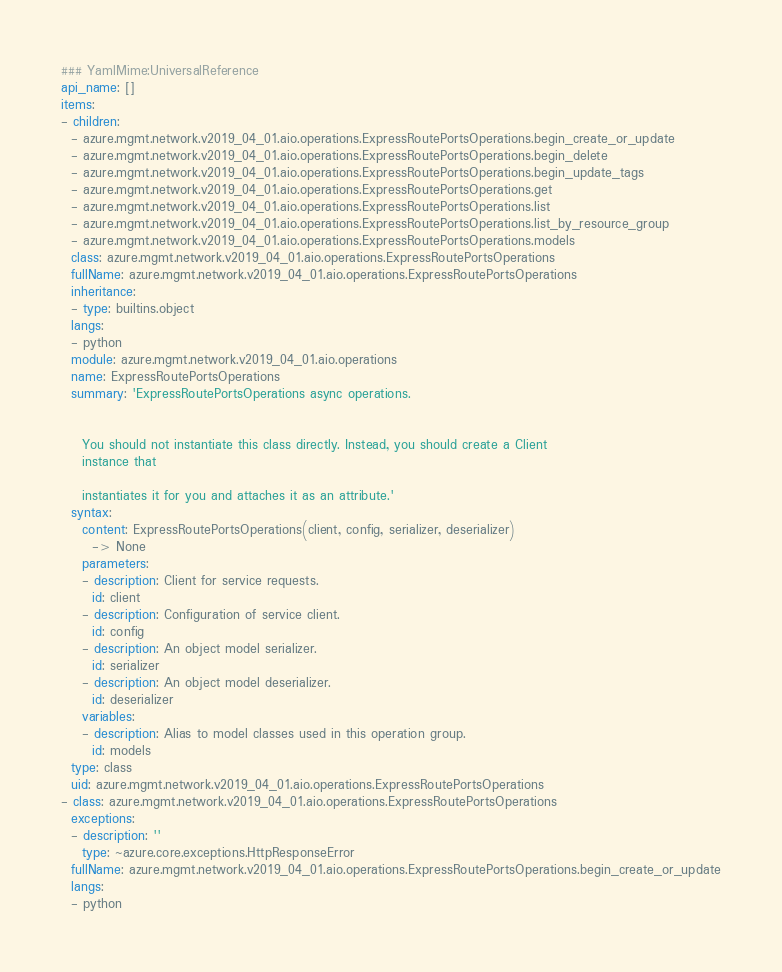Convert code to text. <code><loc_0><loc_0><loc_500><loc_500><_YAML_>### YamlMime:UniversalReference
api_name: []
items:
- children:
  - azure.mgmt.network.v2019_04_01.aio.operations.ExpressRoutePortsOperations.begin_create_or_update
  - azure.mgmt.network.v2019_04_01.aio.operations.ExpressRoutePortsOperations.begin_delete
  - azure.mgmt.network.v2019_04_01.aio.operations.ExpressRoutePortsOperations.begin_update_tags
  - azure.mgmt.network.v2019_04_01.aio.operations.ExpressRoutePortsOperations.get
  - azure.mgmt.network.v2019_04_01.aio.operations.ExpressRoutePortsOperations.list
  - azure.mgmt.network.v2019_04_01.aio.operations.ExpressRoutePortsOperations.list_by_resource_group
  - azure.mgmt.network.v2019_04_01.aio.operations.ExpressRoutePortsOperations.models
  class: azure.mgmt.network.v2019_04_01.aio.operations.ExpressRoutePortsOperations
  fullName: azure.mgmt.network.v2019_04_01.aio.operations.ExpressRoutePortsOperations
  inheritance:
  - type: builtins.object
  langs:
  - python
  module: azure.mgmt.network.v2019_04_01.aio.operations
  name: ExpressRoutePortsOperations
  summary: 'ExpressRoutePortsOperations async operations.


    You should not instantiate this class directly. Instead, you should create a Client
    instance that

    instantiates it for you and attaches it as an attribute.'
  syntax:
    content: ExpressRoutePortsOperations(client, config, serializer, deserializer)
      -> None
    parameters:
    - description: Client for service requests.
      id: client
    - description: Configuration of service client.
      id: config
    - description: An object model serializer.
      id: serializer
    - description: An object model deserializer.
      id: deserializer
    variables:
    - description: Alias to model classes used in this operation group.
      id: models
  type: class
  uid: azure.mgmt.network.v2019_04_01.aio.operations.ExpressRoutePortsOperations
- class: azure.mgmt.network.v2019_04_01.aio.operations.ExpressRoutePortsOperations
  exceptions:
  - description: ''
    type: ~azure.core.exceptions.HttpResponseError
  fullName: azure.mgmt.network.v2019_04_01.aio.operations.ExpressRoutePortsOperations.begin_create_or_update
  langs:
  - python</code> 